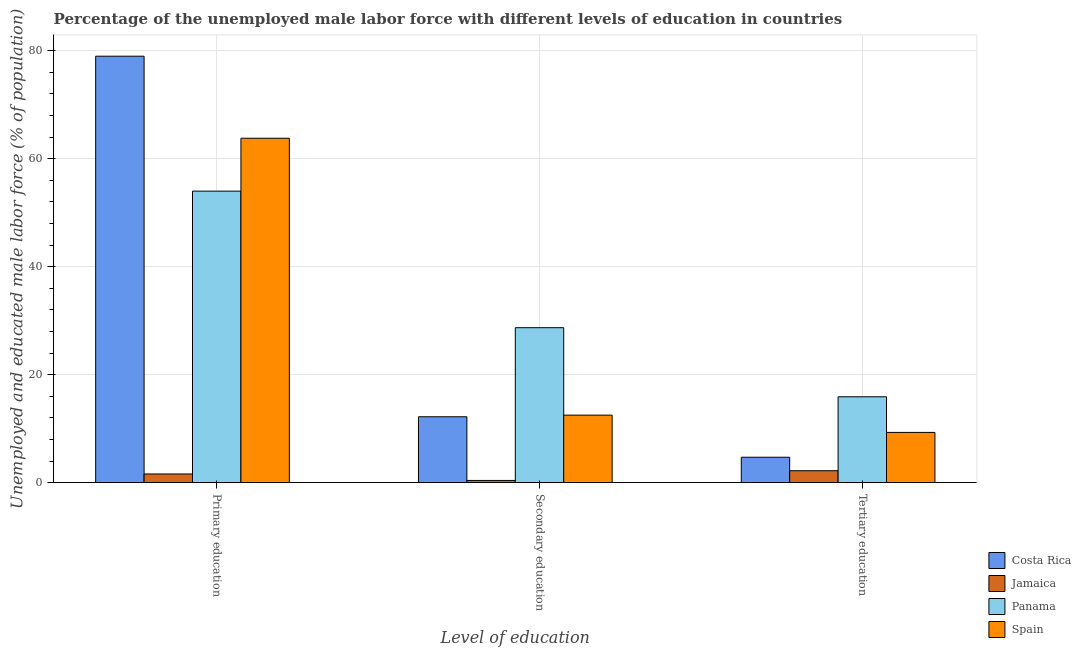How many different coloured bars are there?
Offer a terse response. 4. How many groups of bars are there?
Offer a very short reply. 3. Are the number of bars per tick equal to the number of legend labels?
Give a very brief answer. Yes. What is the label of the 3rd group of bars from the left?
Give a very brief answer. Tertiary education. What is the percentage of male labor force who received tertiary education in Costa Rica?
Keep it short and to the point. 4.7. Across all countries, what is the maximum percentage of male labor force who received primary education?
Your answer should be very brief. 79. Across all countries, what is the minimum percentage of male labor force who received tertiary education?
Your response must be concise. 2.2. In which country was the percentage of male labor force who received secondary education maximum?
Ensure brevity in your answer.  Panama. In which country was the percentage of male labor force who received tertiary education minimum?
Offer a very short reply. Jamaica. What is the total percentage of male labor force who received tertiary education in the graph?
Keep it short and to the point. 32.1. What is the difference between the percentage of male labor force who received primary education in Spain and that in Panama?
Your answer should be compact. 9.8. What is the difference between the percentage of male labor force who received tertiary education in Costa Rica and the percentage of male labor force who received secondary education in Panama?
Provide a short and direct response. -24. What is the average percentage of male labor force who received secondary education per country?
Offer a very short reply. 13.45. What is the difference between the percentage of male labor force who received secondary education and percentage of male labor force who received tertiary education in Jamaica?
Offer a very short reply. -1.8. In how many countries, is the percentage of male labor force who received secondary education greater than 8 %?
Ensure brevity in your answer.  3. What is the ratio of the percentage of male labor force who received primary education in Costa Rica to that in Panama?
Offer a very short reply. 1.46. What is the difference between the highest and the second highest percentage of male labor force who received primary education?
Offer a very short reply. 15.2. What is the difference between the highest and the lowest percentage of male labor force who received primary education?
Your response must be concise. 77.4. Is the sum of the percentage of male labor force who received primary education in Spain and Panama greater than the maximum percentage of male labor force who received secondary education across all countries?
Make the answer very short. Yes. What does the 2nd bar from the left in Primary education represents?
Your response must be concise. Jamaica. What does the 4th bar from the right in Primary education represents?
Keep it short and to the point. Costa Rica. How many bars are there?
Offer a terse response. 12. Where does the legend appear in the graph?
Offer a very short reply. Bottom right. What is the title of the graph?
Ensure brevity in your answer.  Percentage of the unemployed male labor force with different levels of education in countries. What is the label or title of the X-axis?
Provide a short and direct response. Level of education. What is the label or title of the Y-axis?
Your answer should be compact. Unemployed and educated male labor force (% of population). What is the Unemployed and educated male labor force (% of population) in Costa Rica in Primary education?
Offer a very short reply. 79. What is the Unemployed and educated male labor force (% of population) of Jamaica in Primary education?
Give a very brief answer. 1.6. What is the Unemployed and educated male labor force (% of population) in Panama in Primary education?
Your answer should be very brief. 54. What is the Unemployed and educated male labor force (% of population) in Spain in Primary education?
Offer a terse response. 63.8. What is the Unemployed and educated male labor force (% of population) of Costa Rica in Secondary education?
Keep it short and to the point. 12.2. What is the Unemployed and educated male labor force (% of population) in Jamaica in Secondary education?
Your answer should be compact. 0.4. What is the Unemployed and educated male labor force (% of population) in Panama in Secondary education?
Make the answer very short. 28.7. What is the Unemployed and educated male labor force (% of population) of Costa Rica in Tertiary education?
Provide a short and direct response. 4.7. What is the Unemployed and educated male labor force (% of population) in Jamaica in Tertiary education?
Your answer should be compact. 2.2. What is the Unemployed and educated male labor force (% of population) in Panama in Tertiary education?
Ensure brevity in your answer.  15.9. What is the Unemployed and educated male labor force (% of population) in Spain in Tertiary education?
Offer a terse response. 9.3. Across all Level of education, what is the maximum Unemployed and educated male labor force (% of population) of Costa Rica?
Your answer should be very brief. 79. Across all Level of education, what is the maximum Unemployed and educated male labor force (% of population) of Jamaica?
Offer a terse response. 2.2. Across all Level of education, what is the maximum Unemployed and educated male labor force (% of population) in Panama?
Offer a very short reply. 54. Across all Level of education, what is the maximum Unemployed and educated male labor force (% of population) in Spain?
Your response must be concise. 63.8. Across all Level of education, what is the minimum Unemployed and educated male labor force (% of population) in Costa Rica?
Provide a succinct answer. 4.7. Across all Level of education, what is the minimum Unemployed and educated male labor force (% of population) in Jamaica?
Offer a terse response. 0.4. Across all Level of education, what is the minimum Unemployed and educated male labor force (% of population) in Panama?
Keep it short and to the point. 15.9. Across all Level of education, what is the minimum Unemployed and educated male labor force (% of population) in Spain?
Provide a succinct answer. 9.3. What is the total Unemployed and educated male labor force (% of population) in Costa Rica in the graph?
Keep it short and to the point. 95.9. What is the total Unemployed and educated male labor force (% of population) in Jamaica in the graph?
Keep it short and to the point. 4.2. What is the total Unemployed and educated male labor force (% of population) of Panama in the graph?
Provide a short and direct response. 98.6. What is the total Unemployed and educated male labor force (% of population) of Spain in the graph?
Keep it short and to the point. 85.6. What is the difference between the Unemployed and educated male labor force (% of population) in Costa Rica in Primary education and that in Secondary education?
Your answer should be very brief. 66.8. What is the difference between the Unemployed and educated male labor force (% of population) of Jamaica in Primary education and that in Secondary education?
Your answer should be compact. 1.2. What is the difference between the Unemployed and educated male labor force (% of population) of Panama in Primary education and that in Secondary education?
Offer a terse response. 25.3. What is the difference between the Unemployed and educated male labor force (% of population) of Spain in Primary education and that in Secondary education?
Your response must be concise. 51.3. What is the difference between the Unemployed and educated male labor force (% of population) in Costa Rica in Primary education and that in Tertiary education?
Your response must be concise. 74.3. What is the difference between the Unemployed and educated male labor force (% of population) of Jamaica in Primary education and that in Tertiary education?
Provide a short and direct response. -0.6. What is the difference between the Unemployed and educated male labor force (% of population) of Panama in Primary education and that in Tertiary education?
Keep it short and to the point. 38.1. What is the difference between the Unemployed and educated male labor force (% of population) in Spain in Primary education and that in Tertiary education?
Offer a very short reply. 54.5. What is the difference between the Unemployed and educated male labor force (% of population) of Costa Rica in Secondary education and that in Tertiary education?
Provide a succinct answer. 7.5. What is the difference between the Unemployed and educated male labor force (% of population) of Jamaica in Secondary education and that in Tertiary education?
Offer a terse response. -1.8. What is the difference between the Unemployed and educated male labor force (% of population) in Panama in Secondary education and that in Tertiary education?
Provide a succinct answer. 12.8. What is the difference between the Unemployed and educated male labor force (% of population) of Costa Rica in Primary education and the Unemployed and educated male labor force (% of population) of Jamaica in Secondary education?
Your answer should be very brief. 78.6. What is the difference between the Unemployed and educated male labor force (% of population) in Costa Rica in Primary education and the Unemployed and educated male labor force (% of population) in Panama in Secondary education?
Offer a terse response. 50.3. What is the difference between the Unemployed and educated male labor force (% of population) in Costa Rica in Primary education and the Unemployed and educated male labor force (% of population) in Spain in Secondary education?
Provide a succinct answer. 66.5. What is the difference between the Unemployed and educated male labor force (% of population) of Jamaica in Primary education and the Unemployed and educated male labor force (% of population) of Panama in Secondary education?
Make the answer very short. -27.1. What is the difference between the Unemployed and educated male labor force (% of population) in Jamaica in Primary education and the Unemployed and educated male labor force (% of population) in Spain in Secondary education?
Provide a succinct answer. -10.9. What is the difference between the Unemployed and educated male labor force (% of population) of Panama in Primary education and the Unemployed and educated male labor force (% of population) of Spain in Secondary education?
Keep it short and to the point. 41.5. What is the difference between the Unemployed and educated male labor force (% of population) in Costa Rica in Primary education and the Unemployed and educated male labor force (% of population) in Jamaica in Tertiary education?
Keep it short and to the point. 76.8. What is the difference between the Unemployed and educated male labor force (% of population) in Costa Rica in Primary education and the Unemployed and educated male labor force (% of population) in Panama in Tertiary education?
Give a very brief answer. 63.1. What is the difference between the Unemployed and educated male labor force (% of population) of Costa Rica in Primary education and the Unemployed and educated male labor force (% of population) of Spain in Tertiary education?
Make the answer very short. 69.7. What is the difference between the Unemployed and educated male labor force (% of population) of Jamaica in Primary education and the Unemployed and educated male labor force (% of population) of Panama in Tertiary education?
Offer a terse response. -14.3. What is the difference between the Unemployed and educated male labor force (% of population) in Jamaica in Primary education and the Unemployed and educated male labor force (% of population) in Spain in Tertiary education?
Provide a short and direct response. -7.7. What is the difference between the Unemployed and educated male labor force (% of population) in Panama in Primary education and the Unemployed and educated male labor force (% of population) in Spain in Tertiary education?
Your answer should be very brief. 44.7. What is the difference between the Unemployed and educated male labor force (% of population) of Costa Rica in Secondary education and the Unemployed and educated male labor force (% of population) of Panama in Tertiary education?
Provide a succinct answer. -3.7. What is the difference between the Unemployed and educated male labor force (% of population) in Jamaica in Secondary education and the Unemployed and educated male labor force (% of population) in Panama in Tertiary education?
Ensure brevity in your answer.  -15.5. What is the difference between the Unemployed and educated male labor force (% of population) in Panama in Secondary education and the Unemployed and educated male labor force (% of population) in Spain in Tertiary education?
Keep it short and to the point. 19.4. What is the average Unemployed and educated male labor force (% of population) in Costa Rica per Level of education?
Provide a succinct answer. 31.97. What is the average Unemployed and educated male labor force (% of population) of Jamaica per Level of education?
Provide a succinct answer. 1.4. What is the average Unemployed and educated male labor force (% of population) in Panama per Level of education?
Your response must be concise. 32.87. What is the average Unemployed and educated male labor force (% of population) in Spain per Level of education?
Offer a very short reply. 28.53. What is the difference between the Unemployed and educated male labor force (% of population) of Costa Rica and Unemployed and educated male labor force (% of population) of Jamaica in Primary education?
Give a very brief answer. 77.4. What is the difference between the Unemployed and educated male labor force (% of population) of Costa Rica and Unemployed and educated male labor force (% of population) of Panama in Primary education?
Ensure brevity in your answer.  25. What is the difference between the Unemployed and educated male labor force (% of population) in Jamaica and Unemployed and educated male labor force (% of population) in Panama in Primary education?
Ensure brevity in your answer.  -52.4. What is the difference between the Unemployed and educated male labor force (% of population) in Jamaica and Unemployed and educated male labor force (% of population) in Spain in Primary education?
Your answer should be very brief. -62.2. What is the difference between the Unemployed and educated male labor force (% of population) in Panama and Unemployed and educated male labor force (% of population) in Spain in Primary education?
Make the answer very short. -9.8. What is the difference between the Unemployed and educated male labor force (% of population) in Costa Rica and Unemployed and educated male labor force (% of population) in Panama in Secondary education?
Make the answer very short. -16.5. What is the difference between the Unemployed and educated male labor force (% of population) in Jamaica and Unemployed and educated male labor force (% of population) in Panama in Secondary education?
Your response must be concise. -28.3. What is the difference between the Unemployed and educated male labor force (% of population) of Jamaica and Unemployed and educated male labor force (% of population) of Panama in Tertiary education?
Make the answer very short. -13.7. What is the difference between the Unemployed and educated male labor force (% of population) of Jamaica and Unemployed and educated male labor force (% of population) of Spain in Tertiary education?
Make the answer very short. -7.1. What is the ratio of the Unemployed and educated male labor force (% of population) of Costa Rica in Primary education to that in Secondary education?
Offer a very short reply. 6.48. What is the ratio of the Unemployed and educated male labor force (% of population) in Panama in Primary education to that in Secondary education?
Provide a succinct answer. 1.88. What is the ratio of the Unemployed and educated male labor force (% of population) in Spain in Primary education to that in Secondary education?
Give a very brief answer. 5.1. What is the ratio of the Unemployed and educated male labor force (% of population) in Costa Rica in Primary education to that in Tertiary education?
Ensure brevity in your answer.  16.81. What is the ratio of the Unemployed and educated male labor force (% of population) of Jamaica in Primary education to that in Tertiary education?
Offer a very short reply. 0.73. What is the ratio of the Unemployed and educated male labor force (% of population) of Panama in Primary education to that in Tertiary education?
Your answer should be compact. 3.4. What is the ratio of the Unemployed and educated male labor force (% of population) of Spain in Primary education to that in Tertiary education?
Provide a short and direct response. 6.86. What is the ratio of the Unemployed and educated male labor force (% of population) in Costa Rica in Secondary education to that in Tertiary education?
Give a very brief answer. 2.6. What is the ratio of the Unemployed and educated male labor force (% of population) of Jamaica in Secondary education to that in Tertiary education?
Offer a terse response. 0.18. What is the ratio of the Unemployed and educated male labor force (% of population) of Panama in Secondary education to that in Tertiary education?
Offer a terse response. 1.8. What is the ratio of the Unemployed and educated male labor force (% of population) in Spain in Secondary education to that in Tertiary education?
Your response must be concise. 1.34. What is the difference between the highest and the second highest Unemployed and educated male labor force (% of population) of Costa Rica?
Your response must be concise. 66.8. What is the difference between the highest and the second highest Unemployed and educated male labor force (% of population) in Panama?
Make the answer very short. 25.3. What is the difference between the highest and the second highest Unemployed and educated male labor force (% of population) of Spain?
Keep it short and to the point. 51.3. What is the difference between the highest and the lowest Unemployed and educated male labor force (% of population) of Costa Rica?
Provide a short and direct response. 74.3. What is the difference between the highest and the lowest Unemployed and educated male labor force (% of population) of Panama?
Give a very brief answer. 38.1. What is the difference between the highest and the lowest Unemployed and educated male labor force (% of population) of Spain?
Offer a very short reply. 54.5. 